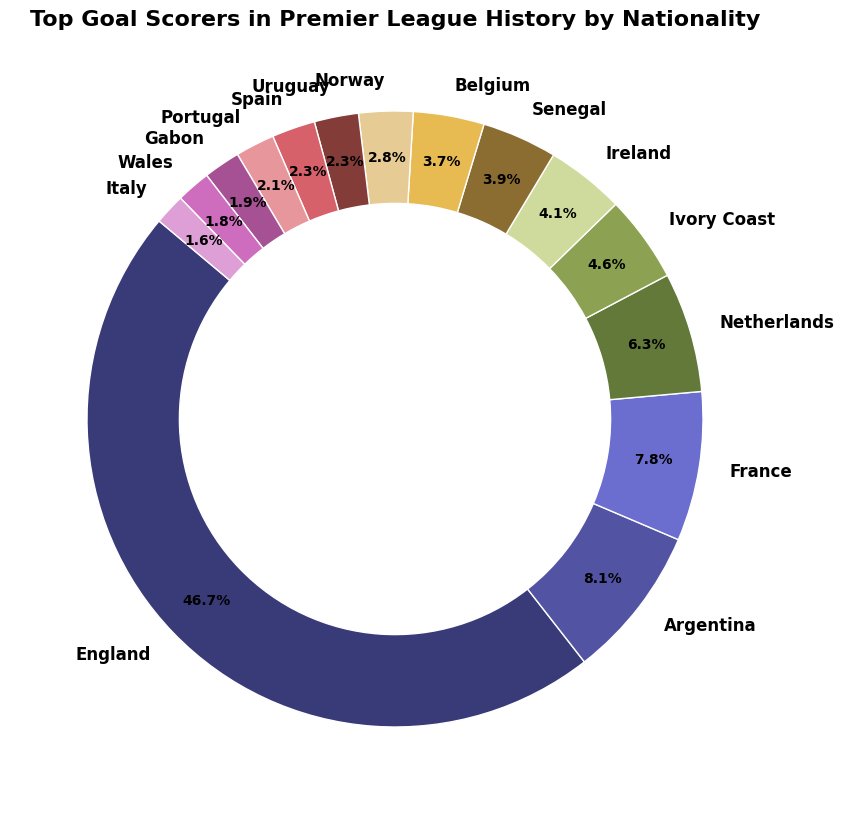Which nationality has the highest percentage of top goal scorers in Premier League History? The chart shows that England has the largest section among all nationalities. By checking the labels and sizes of the wedges, we see that England accounts for the highest percentage.
Answer: England How many goals do the top goal scorers from Argentina and France have combined? To find the combined goals, add the number of goals from Argentina (184) and France (179): 184 + 179 = 363.
Answer: 363 Which nationality has scored more goals, Portugal or Spain? By comparing the sizes and labels, Portugal has 47 goals while Spain has 52 goals. Since 52 > 47, Spain has scored more goals.
Answer: Spain List the nationalities that have scored more than 100 goals. By inspecting the sizes and labels, the nationalities with more than 100 goals are England (1066), Argentina (184), France (179), Netherlands (144), and Ivory Coast (104).
Answer: England, Argentina, France, Netherlands, Ivory Coast What is the difference in goals between Belgium and Norway? By checking the sizes and labels, Belgium has 85 goals, and Norway has 65 goals. The difference is calculated as 85 - 65 = 20.
Answer: 20 Which nationality contributed exactly 44 goals? By looking at the labels and sizes, Gabon is the nationality that contributed exactly 44 goals.
Answer: Gabon Are there more goals scored by players from Ireland or Senegal? Comparing the labels, Ireland has 94 goals, and Senegal has 90 goals. Therefore, Ireland has more goals than Senegal.
Answer: Ireland Which nationality has the smallest percentage of top goal scorers? The smallest wedge in the chart corresponds to Italy. Checking the labels and sizes shows that Italy has the smallest number of goals, 37.
Answer: Italy What is the mean number of goals scored by the nationalities listed? Adding up the goals: 1066 + 184 + 179 + 144 + 104 + 94 + 90 + 85 + 65 + 53 + 52 + 47 + 44 + 41 + 37 = 2185. There are 15 nationalities, so the mean number of goals is 2185 / 15 = 145.67 (rounded to two decimal places).
Answer: 145.67 How many nationalities have scored fewer than 50 goals? Checking the wedges and labels, the nationalities with fewer than 50 goals are Portugal (47), Gabon (44), Wales (41), and Italy (37), totaling 4 nationalities.
Answer: 4 